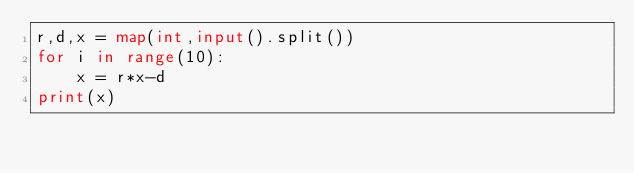<code> <loc_0><loc_0><loc_500><loc_500><_Python_>r,d,x = map(int,input().split())
for i in range(10):
    x = r*x-d
print(x)
</code> 